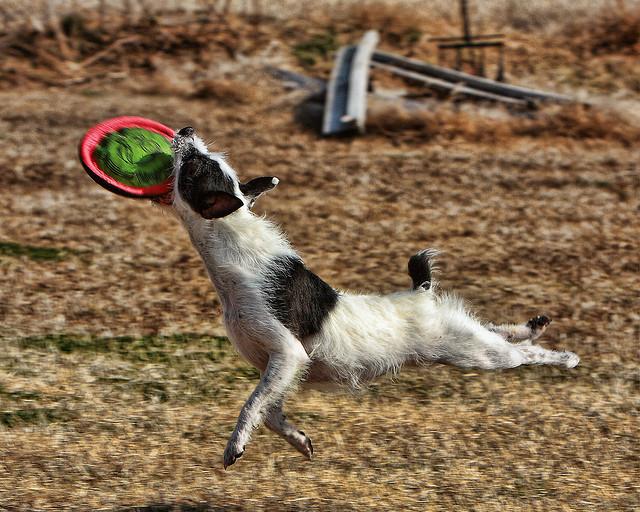Why is the grass brown?
Answer briefly. Dry. What is in the dog's mouth?
Quick response, please. Frisbee. How many of the dog's paws are touching the ground?
Keep it brief. 0. 